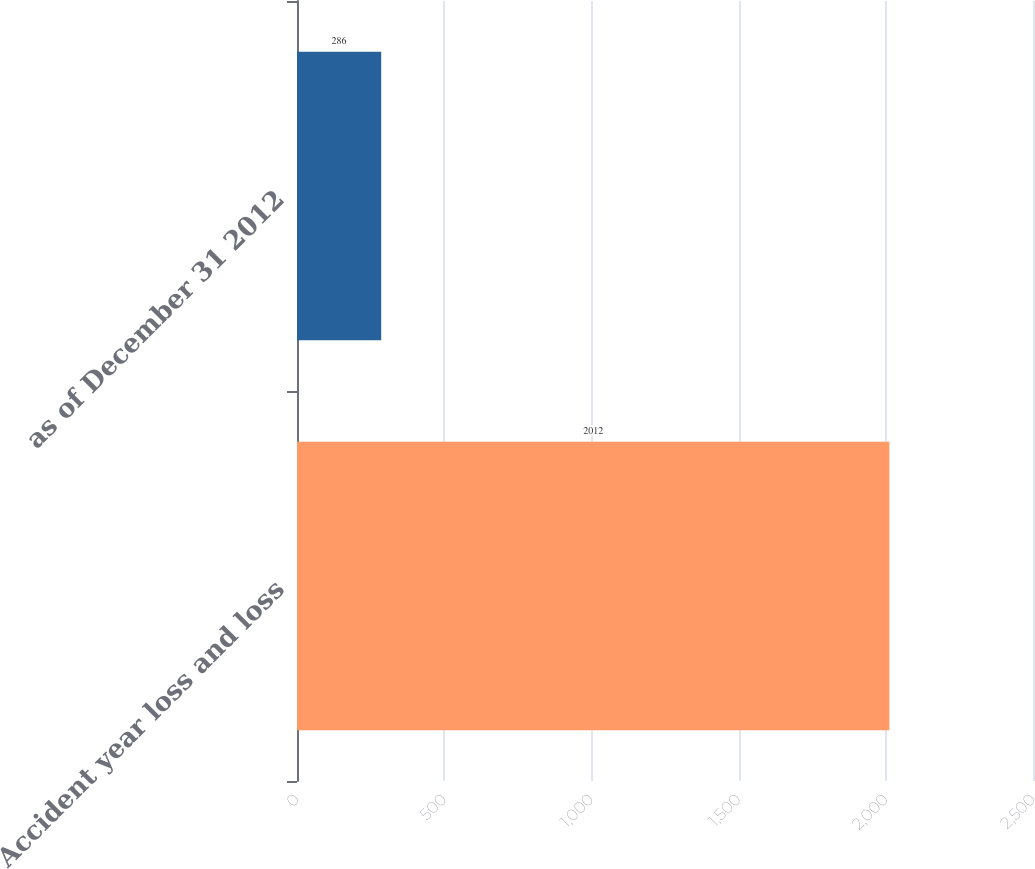Convert chart. <chart><loc_0><loc_0><loc_500><loc_500><bar_chart><fcel>Accident year loss and loss<fcel>as of December 31 2012<nl><fcel>2012<fcel>286<nl></chart> 